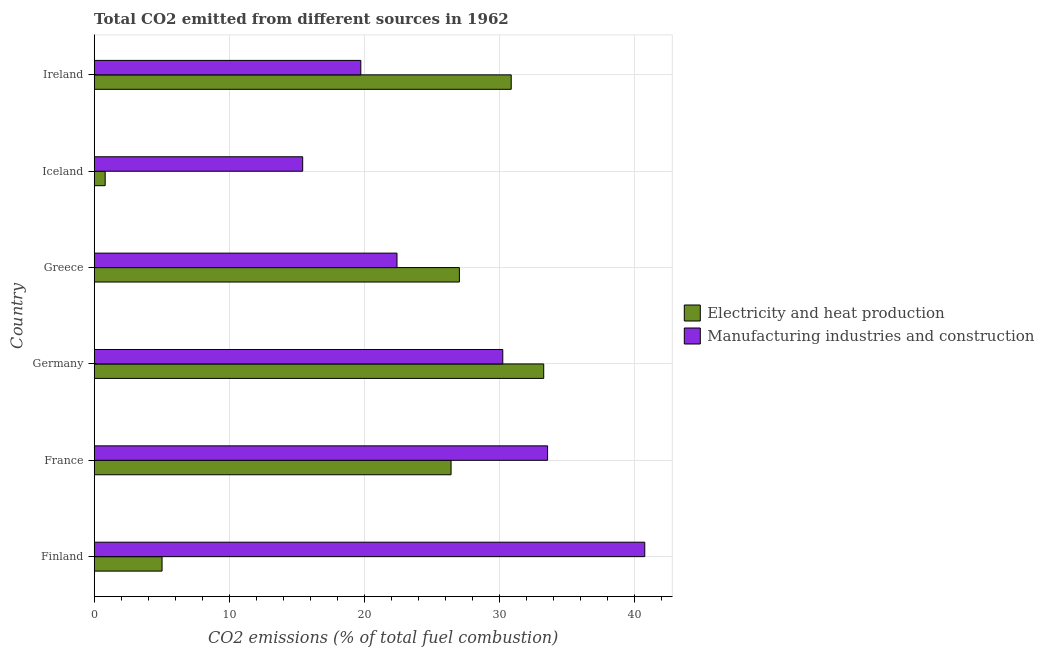How many different coloured bars are there?
Provide a short and direct response. 2. Are the number of bars per tick equal to the number of legend labels?
Provide a succinct answer. Yes. How many bars are there on the 1st tick from the bottom?
Your answer should be very brief. 2. What is the co2 emissions due to electricity and heat production in Germany?
Offer a very short reply. 33.31. Across all countries, what is the maximum co2 emissions due to manufacturing industries?
Offer a very short reply. 40.79. Across all countries, what is the minimum co2 emissions due to manufacturing industries?
Ensure brevity in your answer.  15.45. In which country was the co2 emissions due to electricity and heat production maximum?
Give a very brief answer. Germany. What is the total co2 emissions due to manufacturing industries in the graph?
Provide a succinct answer. 162.29. What is the difference between the co2 emissions due to manufacturing industries in France and that in Germany?
Offer a terse response. 3.32. What is the difference between the co2 emissions due to manufacturing industries in Greece and the co2 emissions due to electricity and heat production in Iceland?
Offer a very short reply. 21.62. What is the average co2 emissions due to manufacturing industries per country?
Provide a short and direct response. 27.05. What is the difference between the co2 emissions due to manufacturing industries and co2 emissions due to electricity and heat production in Greece?
Give a very brief answer. -4.62. In how many countries, is the co2 emissions due to electricity and heat production greater than 14 %?
Offer a very short reply. 4. What is the ratio of the co2 emissions due to electricity and heat production in France to that in Ireland?
Offer a very short reply. 0.86. Is the co2 emissions due to electricity and heat production in Germany less than that in Ireland?
Your answer should be very brief. No. Is the difference between the co2 emissions due to manufacturing industries in France and Greece greater than the difference between the co2 emissions due to electricity and heat production in France and Greece?
Your answer should be very brief. Yes. What is the difference between the highest and the second highest co2 emissions due to manufacturing industries?
Keep it short and to the point. 7.2. What is the difference between the highest and the lowest co2 emissions due to manufacturing industries?
Offer a terse response. 25.34. In how many countries, is the co2 emissions due to electricity and heat production greater than the average co2 emissions due to electricity and heat production taken over all countries?
Your answer should be very brief. 4. Is the sum of the co2 emissions due to manufacturing industries in Finland and Ireland greater than the maximum co2 emissions due to electricity and heat production across all countries?
Your response must be concise. Yes. What does the 1st bar from the top in Iceland represents?
Your answer should be very brief. Manufacturing industries and construction. What does the 2nd bar from the bottom in Greece represents?
Give a very brief answer. Manufacturing industries and construction. How many countries are there in the graph?
Provide a succinct answer. 6. Does the graph contain grids?
Your response must be concise. Yes. How are the legend labels stacked?
Your answer should be very brief. Vertical. What is the title of the graph?
Offer a terse response. Total CO2 emitted from different sources in 1962. What is the label or title of the X-axis?
Provide a short and direct response. CO2 emissions (% of total fuel combustion). What is the label or title of the Y-axis?
Give a very brief answer. Country. What is the CO2 emissions (% of total fuel combustion) of Electricity and heat production in Finland?
Ensure brevity in your answer.  5.03. What is the CO2 emissions (% of total fuel combustion) in Manufacturing industries and construction in Finland?
Offer a very short reply. 40.79. What is the CO2 emissions (% of total fuel combustion) in Electricity and heat production in France?
Your answer should be very brief. 26.44. What is the CO2 emissions (% of total fuel combustion) in Manufacturing industries and construction in France?
Keep it short and to the point. 33.59. What is the CO2 emissions (% of total fuel combustion) in Electricity and heat production in Germany?
Your answer should be very brief. 33.31. What is the CO2 emissions (% of total fuel combustion) in Manufacturing industries and construction in Germany?
Your answer should be very brief. 30.27. What is the CO2 emissions (% of total fuel combustion) in Electricity and heat production in Greece?
Give a very brief answer. 27.06. What is the CO2 emissions (% of total fuel combustion) of Manufacturing industries and construction in Greece?
Offer a terse response. 22.44. What is the CO2 emissions (% of total fuel combustion) of Electricity and heat production in Iceland?
Ensure brevity in your answer.  0.81. What is the CO2 emissions (% of total fuel combustion) in Manufacturing industries and construction in Iceland?
Offer a terse response. 15.45. What is the CO2 emissions (% of total fuel combustion) in Electricity and heat production in Ireland?
Your answer should be very brief. 30.9. What is the CO2 emissions (% of total fuel combustion) of Manufacturing industries and construction in Ireland?
Give a very brief answer. 19.75. Across all countries, what is the maximum CO2 emissions (% of total fuel combustion) in Electricity and heat production?
Give a very brief answer. 33.31. Across all countries, what is the maximum CO2 emissions (% of total fuel combustion) in Manufacturing industries and construction?
Your response must be concise. 40.79. Across all countries, what is the minimum CO2 emissions (% of total fuel combustion) of Electricity and heat production?
Offer a very short reply. 0.81. Across all countries, what is the minimum CO2 emissions (% of total fuel combustion) of Manufacturing industries and construction?
Keep it short and to the point. 15.45. What is the total CO2 emissions (% of total fuel combustion) of Electricity and heat production in the graph?
Your response must be concise. 123.54. What is the total CO2 emissions (% of total fuel combustion) of Manufacturing industries and construction in the graph?
Give a very brief answer. 162.29. What is the difference between the CO2 emissions (% of total fuel combustion) of Electricity and heat production in Finland and that in France?
Provide a short and direct response. -21.41. What is the difference between the CO2 emissions (% of total fuel combustion) in Manufacturing industries and construction in Finland and that in France?
Give a very brief answer. 7.2. What is the difference between the CO2 emissions (% of total fuel combustion) of Electricity and heat production in Finland and that in Germany?
Keep it short and to the point. -28.28. What is the difference between the CO2 emissions (% of total fuel combustion) in Manufacturing industries and construction in Finland and that in Germany?
Your response must be concise. 10.52. What is the difference between the CO2 emissions (% of total fuel combustion) of Electricity and heat production in Finland and that in Greece?
Give a very brief answer. -22.03. What is the difference between the CO2 emissions (% of total fuel combustion) of Manufacturing industries and construction in Finland and that in Greece?
Provide a succinct answer. 18.36. What is the difference between the CO2 emissions (% of total fuel combustion) in Electricity and heat production in Finland and that in Iceland?
Provide a short and direct response. 4.22. What is the difference between the CO2 emissions (% of total fuel combustion) in Manufacturing industries and construction in Finland and that in Iceland?
Make the answer very short. 25.34. What is the difference between the CO2 emissions (% of total fuel combustion) of Electricity and heat production in Finland and that in Ireland?
Give a very brief answer. -25.87. What is the difference between the CO2 emissions (% of total fuel combustion) in Manufacturing industries and construction in Finland and that in Ireland?
Make the answer very short. 21.04. What is the difference between the CO2 emissions (% of total fuel combustion) of Electricity and heat production in France and that in Germany?
Provide a short and direct response. -6.87. What is the difference between the CO2 emissions (% of total fuel combustion) in Manufacturing industries and construction in France and that in Germany?
Offer a terse response. 3.32. What is the difference between the CO2 emissions (% of total fuel combustion) of Electricity and heat production in France and that in Greece?
Your response must be concise. -0.62. What is the difference between the CO2 emissions (% of total fuel combustion) in Manufacturing industries and construction in France and that in Greece?
Provide a succinct answer. 11.16. What is the difference between the CO2 emissions (% of total fuel combustion) of Electricity and heat production in France and that in Iceland?
Give a very brief answer. 25.63. What is the difference between the CO2 emissions (% of total fuel combustion) in Manufacturing industries and construction in France and that in Iceland?
Provide a short and direct response. 18.14. What is the difference between the CO2 emissions (% of total fuel combustion) of Electricity and heat production in France and that in Ireland?
Offer a very short reply. -4.46. What is the difference between the CO2 emissions (% of total fuel combustion) in Manufacturing industries and construction in France and that in Ireland?
Your answer should be compact. 13.84. What is the difference between the CO2 emissions (% of total fuel combustion) in Electricity and heat production in Germany and that in Greece?
Ensure brevity in your answer.  6.25. What is the difference between the CO2 emissions (% of total fuel combustion) in Manufacturing industries and construction in Germany and that in Greece?
Offer a very short reply. 7.84. What is the difference between the CO2 emissions (% of total fuel combustion) of Electricity and heat production in Germany and that in Iceland?
Ensure brevity in your answer.  32.49. What is the difference between the CO2 emissions (% of total fuel combustion) in Manufacturing industries and construction in Germany and that in Iceland?
Keep it short and to the point. 14.82. What is the difference between the CO2 emissions (% of total fuel combustion) of Electricity and heat production in Germany and that in Ireland?
Provide a succinct answer. 2.41. What is the difference between the CO2 emissions (% of total fuel combustion) in Manufacturing industries and construction in Germany and that in Ireland?
Your answer should be compact. 10.52. What is the difference between the CO2 emissions (% of total fuel combustion) in Electricity and heat production in Greece and that in Iceland?
Provide a short and direct response. 26.24. What is the difference between the CO2 emissions (% of total fuel combustion) of Manufacturing industries and construction in Greece and that in Iceland?
Your answer should be compact. 6.99. What is the difference between the CO2 emissions (% of total fuel combustion) in Electricity and heat production in Greece and that in Ireland?
Ensure brevity in your answer.  -3.84. What is the difference between the CO2 emissions (% of total fuel combustion) of Manufacturing industries and construction in Greece and that in Ireland?
Give a very brief answer. 2.68. What is the difference between the CO2 emissions (% of total fuel combustion) in Electricity and heat production in Iceland and that in Ireland?
Your answer should be compact. -30.08. What is the difference between the CO2 emissions (% of total fuel combustion) in Manufacturing industries and construction in Iceland and that in Ireland?
Your answer should be compact. -4.31. What is the difference between the CO2 emissions (% of total fuel combustion) in Electricity and heat production in Finland and the CO2 emissions (% of total fuel combustion) in Manufacturing industries and construction in France?
Provide a succinct answer. -28.56. What is the difference between the CO2 emissions (% of total fuel combustion) of Electricity and heat production in Finland and the CO2 emissions (% of total fuel combustion) of Manufacturing industries and construction in Germany?
Offer a terse response. -25.24. What is the difference between the CO2 emissions (% of total fuel combustion) in Electricity and heat production in Finland and the CO2 emissions (% of total fuel combustion) in Manufacturing industries and construction in Greece?
Give a very brief answer. -17.41. What is the difference between the CO2 emissions (% of total fuel combustion) of Electricity and heat production in Finland and the CO2 emissions (% of total fuel combustion) of Manufacturing industries and construction in Iceland?
Ensure brevity in your answer.  -10.42. What is the difference between the CO2 emissions (% of total fuel combustion) in Electricity and heat production in Finland and the CO2 emissions (% of total fuel combustion) in Manufacturing industries and construction in Ireland?
Provide a succinct answer. -14.73. What is the difference between the CO2 emissions (% of total fuel combustion) of Electricity and heat production in France and the CO2 emissions (% of total fuel combustion) of Manufacturing industries and construction in Germany?
Your answer should be compact. -3.83. What is the difference between the CO2 emissions (% of total fuel combustion) in Electricity and heat production in France and the CO2 emissions (% of total fuel combustion) in Manufacturing industries and construction in Greece?
Provide a short and direct response. 4.01. What is the difference between the CO2 emissions (% of total fuel combustion) of Electricity and heat production in France and the CO2 emissions (% of total fuel combustion) of Manufacturing industries and construction in Iceland?
Make the answer very short. 10.99. What is the difference between the CO2 emissions (% of total fuel combustion) in Electricity and heat production in France and the CO2 emissions (% of total fuel combustion) in Manufacturing industries and construction in Ireland?
Offer a very short reply. 6.69. What is the difference between the CO2 emissions (% of total fuel combustion) of Electricity and heat production in Germany and the CO2 emissions (% of total fuel combustion) of Manufacturing industries and construction in Greece?
Your response must be concise. 10.87. What is the difference between the CO2 emissions (% of total fuel combustion) in Electricity and heat production in Germany and the CO2 emissions (% of total fuel combustion) in Manufacturing industries and construction in Iceland?
Keep it short and to the point. 17.86. What is the difference between the CO2 emissions (% of total fuel combustion) in Electricity and heat production in Germany and the CO2 emissions (% of total fuel combustion) in Manufacturing industries and construction in Ireland?
Your response must be concise. 13.55. What is the difference between the CO2 emissions (% of total fuel combustion) of Electricity and heat production in Greece and the CO2 emissions (% of total fuel combustion) of Manufacturing industries and construction in Iceland?
Your answer should be compact. 11.61. What is the difference between the CO2 emissions (% of total fuel combustion) of Electricity and heat production in Greece and the CO2 emissions (% of total fuel combustion) of Manufacturing industries and construction in Ireland?
Give a very brief answer. 7.3. What is the difference between the CO2 emissions (% of total fuel combustion) of Electricity and heat production in Iceland and the CO2 emissions (% of total fuel combustion) of Manufacturing industries and construction in Ireland?
Your answer should be compact. -18.94. What is the average CO2 emissions (% of total fuel combustion) in Electricity and heat production per country?
Give a very brief answer. 20.59. What is the average CO2 emissions (% of total fuel combustion) in Manufacturing industries and construction per country?
Your response must be concise. 27.05. What is the difference between the CO2 emissions (% of total fuel combustion) in Electricity and heat production and CO2 emissions (% of total fuel combustion) in Manufacturing industries and construction in Finland?
Keep it short and to the point. -35.76. What is the difference between the CO2 emissions (% of total fuel combustion) in Electricity and heat production and CO2 emissions (% of total fuel combustion) in Manufacturing industries and construction in France?
Provide a short and direct response. -7.15. What is the difference between the CO2 emissions (% of total fuel combustion) in Electricity and heat production and CO2 emissions (% of total fuel combustion) in Manufacturing industries and construction in Germany?
Ensure brevity in your answer.  3.03. What is the difference between the CO2 emissions (% of total fuel combustion) in Electricity and heat production and CO2 emissions (% of total fuel combustion) in Manufacturing industries and construction in Greece?
Offer a very short reply. 4.62. What is the difference between the CO2 emissions (% of total fuel combustion) in Electricity and heat production and CO2 emissions (% of total fuel combustion) in Manufacturing industries and construction in Iceland?
Provide a succinct answer. -14.63. What is the difference between the CO2 emissions (% of total fuel combustion) of Electricity and heat production and CO2 emissions (% of total fuel combustion) of Manufacturing industries and construction in Ireland?
Provide a succinct answer. 11.14. What is the ratio of the CO2 emissions (% of total fuel combustion) in Electricity and heat production in Finland to that in France?
Ensure brevity in your answer.  0.19. What is the ratio of the CO2 emissions (% of total fuel combustion) in Manufacturing industries and construction in Finland to that in France?
Your response must be concise. 1.21. What is the ratio of the CO2 emissions (% of total fuel combustion) in Electricity and heat production in Finland to that in Germany?
Your response must be concise. 0.15. What is the ratio of the CO2 emissions (% of total fuel combustion) of Manufacturing industries and construction in Finland to that in Germany?
Keep it short and to the point. 1.35. What is the ratio of the CO2 emissions (% of total fuel combustion) in Electricity and heat production in Finland to that in Greece?
Offer a very short reply. 0.19. What is the ratio of the CO2 emissions (% of total fuel combustion) in Manufacturing industries and construction in Finland to that in Greece?
Offer a very short reply. 1.82. What is the ratio of the CO2 emissions (% of total fuel combustion) of Electricity and heat production in Finland to that in Iceland?
Keep it short and to the point. 6.18. What is the ratio of the CO2 emissions (% of total fuel combustion) of Manufacturing industries and construction in Finland to that in Iceland?
Offer a very short reply. 2.64. What is the ratio of the CO2 emissions (% of total fuel combustion) in Electricity and heat production in Finland to that in Ireland?
Provide a short and direct response. 0.16. What is the ratio of the CO2 emissions (% of total fuel combustion) of Manufacturing industries and construction in Finland to that in Ireland?
Provide a short and direct response. 2.06. What is the ratio of the CO2 emissions (% of total fuel combustion) of Electricity and heat production in France to that in Germany?
Ensure brevity in your answer.  0.79. What is the ratio of the CO2 emissions (% of total fuel combustion) in Manufacturing industries and construction in France to that in Germany?
Offer a very short reply. 1.11. What is the ratio of the CO2 emissions (% of total fuel combustion) of Electricity and heat production in France to that in Greece?
Make the answer very short. 0.98. What is the ratio of the CO2 emissions (% of total fuel combustion) of Manufacturing industries and construction in France to that in Greece?
Offer a very short reply. 1.5. What is the ratio of the CO2 emissions (% of total fuel combustion) of Electricity and heat production in France to that in Iceland?
Provide a succinct answer. 32.52. What is the ratio of the CO2 emissions (% of total fuel combustion) of Manufacturing industries and construction in France to that in Iceland?
Offer a terse response. 2.17. What is the ratio of the CO2 emissions (% of total fuel combustion) in Electricity and heat production in France to that in Ireland?
Give a very brief answer. 0.86. What is the ratio of the CO2 emissions (% of total fuel combustion) of Manufacturing industries and construction in France to that in Ireland?
Provide a short and direct response. 1.7. What is the ratio of the CO2 emissions (% of total fuel combustion) of Electricity and heat production in Germany to that in Greece?
Keep it short and to the point. 1.23. What is the ratio of the CO2 emissions (% of total fuel combustion) of Manufacturing industries and construction in Germany to that in Greece?
Offer a terse response. 1.35. What is the ratio of the CO2 emissions (% of total fuel combustion) of Electricity and heat production in Germany to that in Iceland?
Keep it short and to the point. 40.97. What is the ratio of the CO2 emissions (% of total fuel combustion) of Manufacturing industries and construction in Germany to that in Iceland?
Your answer should be compact. 1.96. What is the ratio of the CO2 emissions (% of total fuel combustion) in Electricity and heat production in Germany to that in Ireland?
Ensure brevity in your answer.  1.08. What is the ratio of the CO2 emissions (% of total fuel combustion) of Manufacturing industries and construction in Germany to that in Ireland?
Offer a very short reply. 1.53. What is the ratio of the CO2 emissions (% of total fuel combustion) in Electricity and heat production in Greece to that in Iceland?
Provide a succinct answer. 33.28. What is the ratio of the CO2 emissions (% of total fuel combustion) of Manufacturing industries and construction in Greece to that in Iceland?
Make the answer very short. 1.45. What is the ratio of the CO2 emissions (% of total fuel combustion) in Electricity and heat production in Greece to that in Ireland?
Your answer should be compact. 0.88. What is the ratio of the CO2 emissions (% of total fuel combustion) in Manufacturing industries and construction in Greece to that in Ireland?
Provide a short and direct response. 1.14. What is the ratio of the CO2 emissions (% of total fuel combustion) of Electricity and heat production in Iceland to that in Ireland?
Your answer should be compact. 0.03. What is the ratio of the CO2 emissions (% of total fuel combustion) in Manufacturing industries and construction in Iceland to that in Ireland?
Keep it short and to the point. 0.78. What is the difference between the highest and the second highest CO2 emissions (% of total fuel combustion) in Electricity and heat production?
Ensure brevity in your answer.  2.41. What is the difference between the highest and the second highest CO2 emissions (% of total fuel combustion) in Manufacturing industries and construction?
Your response must be concise. 7.2. What is the difference between the highest and the lowest CO2 emissions (% of total fuel combustion) of Electricity and heat production?
Ensure brevity in your answer.  32.49. What is the difference between the highest and the lowest CO2 emissions (% of total fuel combustion) of Manufacturing industries and construction?
Provide a short and direct response. 25.34. 